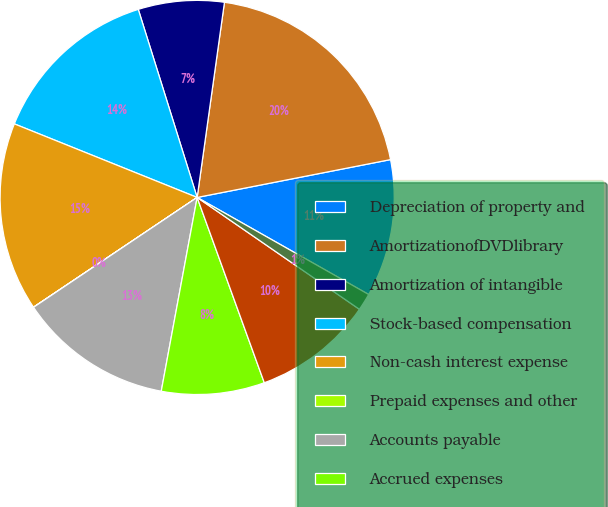<chart> <loc_0><loc_0><loc_500><loc_500><pie_chart><fcel>Depreciation of property and<fcel>AmortizationofDVDlibrary<fcel>Amortization of intangible<fcel>Stock-based compensation<fcel>Non-cash interest expense<fcel>Prepaid expenses and other<fcel>Accounts payable<fcel>Accrued expenses<fcel>Deferred revenue<fcel>Deferredrent<nl><fcel>11.27%<fcel>19.71%<fcel>7.04%<fcel>14.08%<fcel>15.49%<fcel>0.01%<fcel>12.67%<fcel>8.45%<fcel>9.86%<fcel>1.41%<nl></chart> 